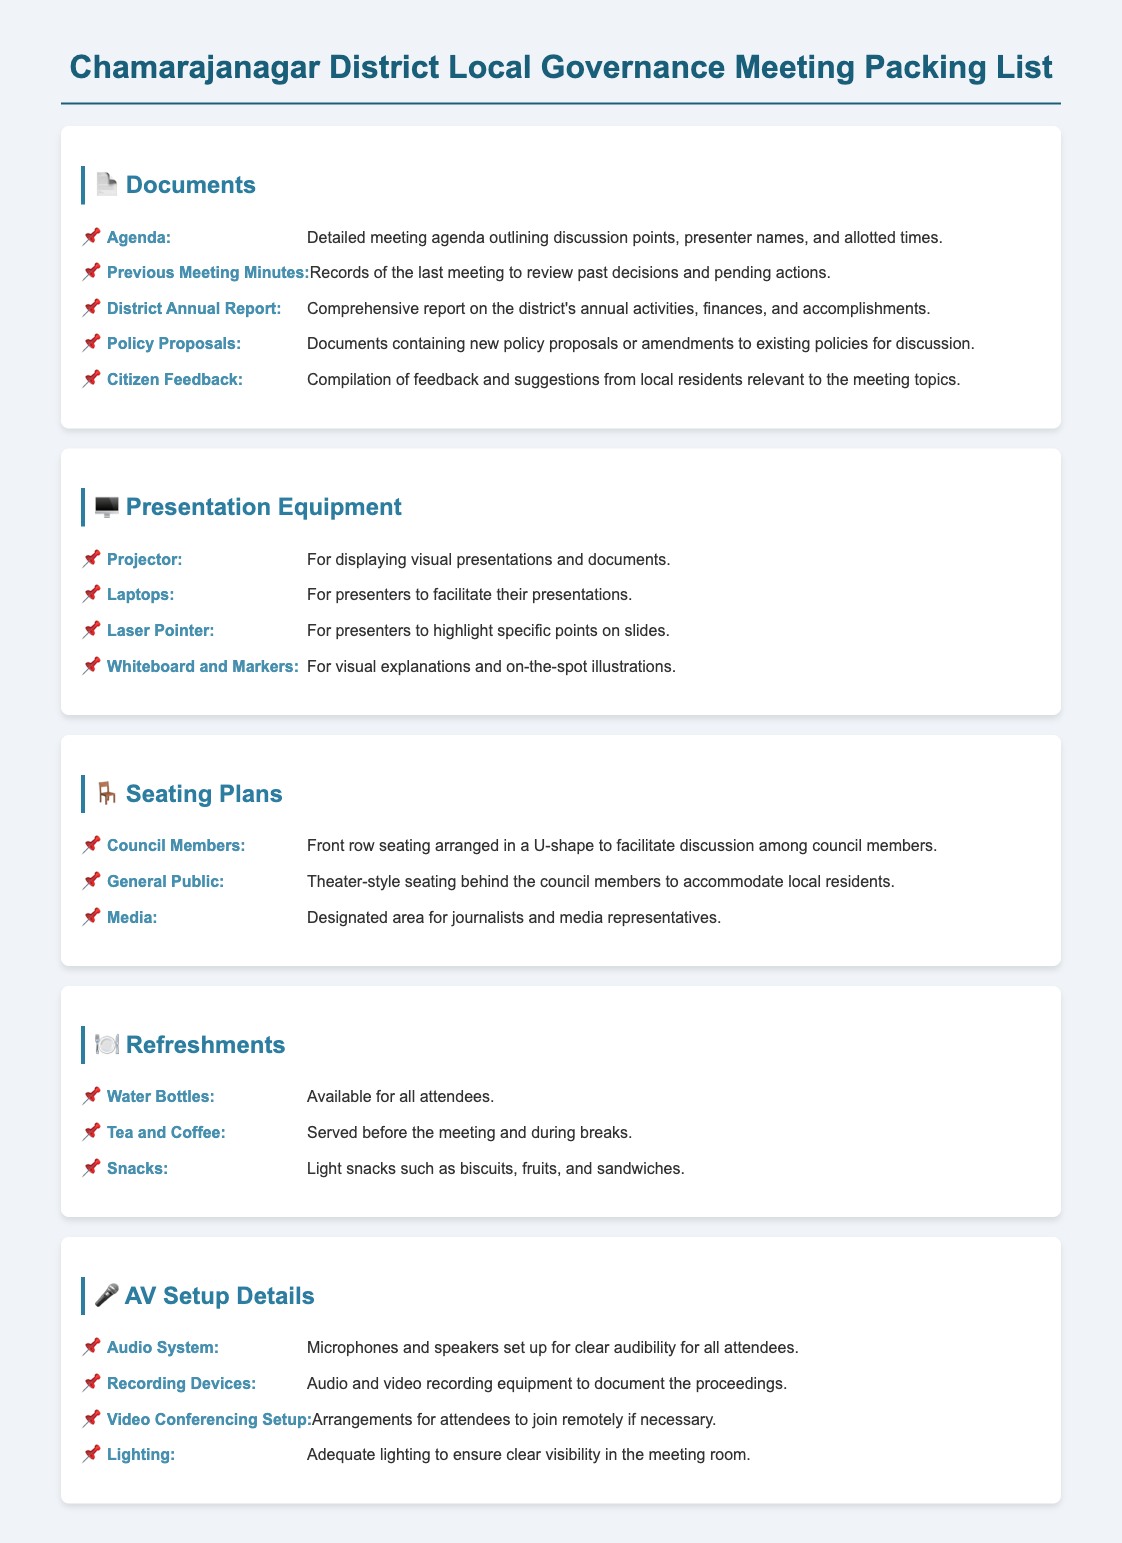What is the meeting agenda? The meeting agenda outlines discussion points, presenter names, and allotted times, which is detailed in the documents section of the packing list.
Answer: Detailed meeting agenda What is included in the refreshments? The refreshments section lists the items provided for attendees during the meeting, covering beverages and snacks.
Answer: Water Bottles, Tea and Coffee, Snacks How many types of seating arrangements are there? The seating plans section outlines three distinct seating arrangements; one for council members, the general public, and media.
Answer: Three What document contains new policy proposals? The documents section mentions the specific document that includes new policy proposals or amendments for discussion during the meeting.
Answer: Policy Proposals What audio system components are mentioned? The AV setup details specify the components included in the audio system necessary for clear audibility.
Answer: Microphones and speakers What equipment is necessary for video conferencing? The AV setup mentions arrangements required for participants who may join the meeting remotely.
Answer: Video Conferencing Setup What item is listed under presentation equipment for highlighting slides? The presentation equipment section indicates a specific tool used by presenters to emphasize particular points during their presentations.
Answer: Laser Pointer What type of seating is arranged for the general public? The seating plans section describes how the public is accommodated during the meeting, specifically the style of seating used.
Answer: Theater-style seating How are minutes from the previous meeting utilized? The documents section explains the purpose of the previous meeting minutes, which serve to review past decisions and actions.
Answer: To review past decisions and pending actions 